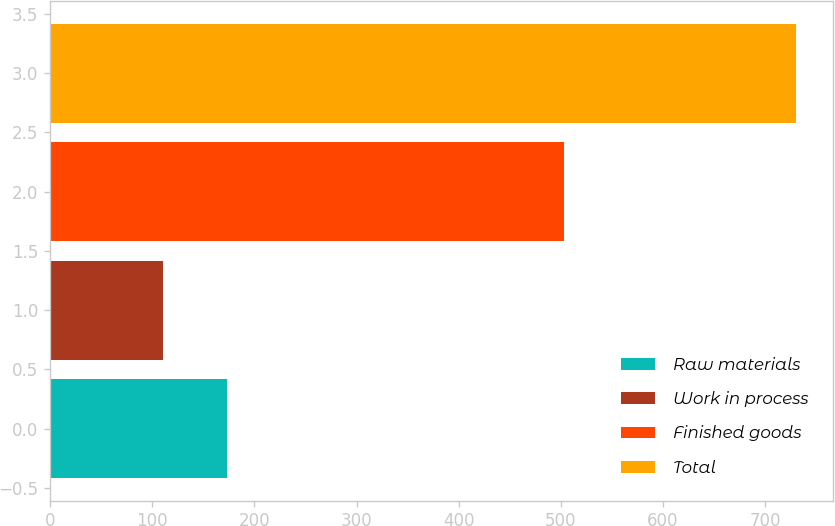<chart> <loc_0><loc_0><loc_500><loc_500><bar_chart><fcel>Raw materials<fcel>Work in process<fcel>Finished goods<fcel>Total<nl><fcel>172.83<fcel>110.9<fcel>502.7<fcel>730.2<nl></chart> 